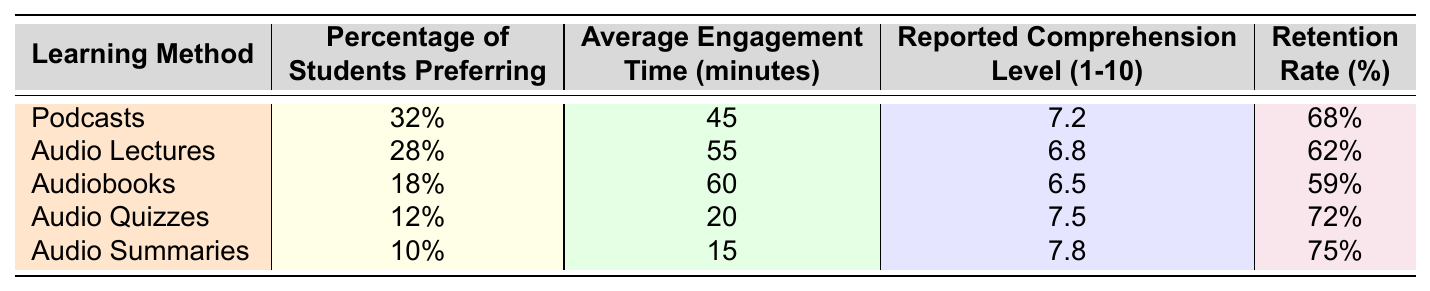What is the percentage of students who prefer podcasts? The table shows that 32% of students prefer podcasts.
Answer: 32% Which audio learning method has the highest reported comprehension level? The highest reported comprehension level is 7.8 for Audio Summaries.
Answer: Audio Summaries What is the average retention rate for audio quizzes and audiobooks combined? Adding the retention rates: 72% (Audio Quizzes) + 59% (Audiobooks) = 131%, then dividing by 2 gives an average of 65.5%.
Answer: 65.5% Is the average engagement time for audiobooks greater than that for audio quizzes? The average engagement time for audiobooks is 60 minutes, while for audio quizzes, it is 20 minutes, so the statement is true.
Answer: Yes What is the total percentage of students who prefer audio lectures and audio summaries? Adding the percentages gives: 28% (Audio Lectures) + 10% (Audio Summaries) = 38%.
Answer: 38% Which audio learning method has the lowest retention rate? The lowest retention rate is for audiobooks, at 59%.
Answer: Audiobooks What is the comprehension difference between podcasts and audio lectures? The comprehension level for podcasts is 7.2, while it is 6.8 for audio lectures, so the difference is 7.2 - 6.8 = 0.4.
Answer: 0.4 What method has both the highest average engagement time and the lowest percentage of students preferring? Audio lectures have the highest engagement time (55 min) and audio summaries have the lowest preference (10%).
Answer: Audio summaries Which audio learning method is most preferred by students and what is its average engagement time? Podcasts are most preferred at 32%, and the average engagement time is 45 minutes.
Answer: 45 minutes Does the data suggest that higher engagement time correlates with higher retention rates based on audio quizzes and audio summaries? Audio quizzes have a lower engagement time (20 min) but a higher retention rate (72%), while audio summaries have a higher engagement time (15 min) and an even higher retention rate (75%), suggesting no strong correlation in this case.
Answer: No 